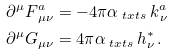<formula> <loc_0><loc_0><loc_500><loc_500>\partial ^ { \mu } F ^ { a } _ { \, \mu \nu } & = - 4 \pi \alpha _ { \ t x t { s } } \, k ^ { a } _ { \, \nu } \\ \partial ^ { \mu } G _ { \mu \nu } & = 4 \pi \alpha _ { \ t x t { s } } \, h ^ { * } _ { \nu } \, .</formula> 